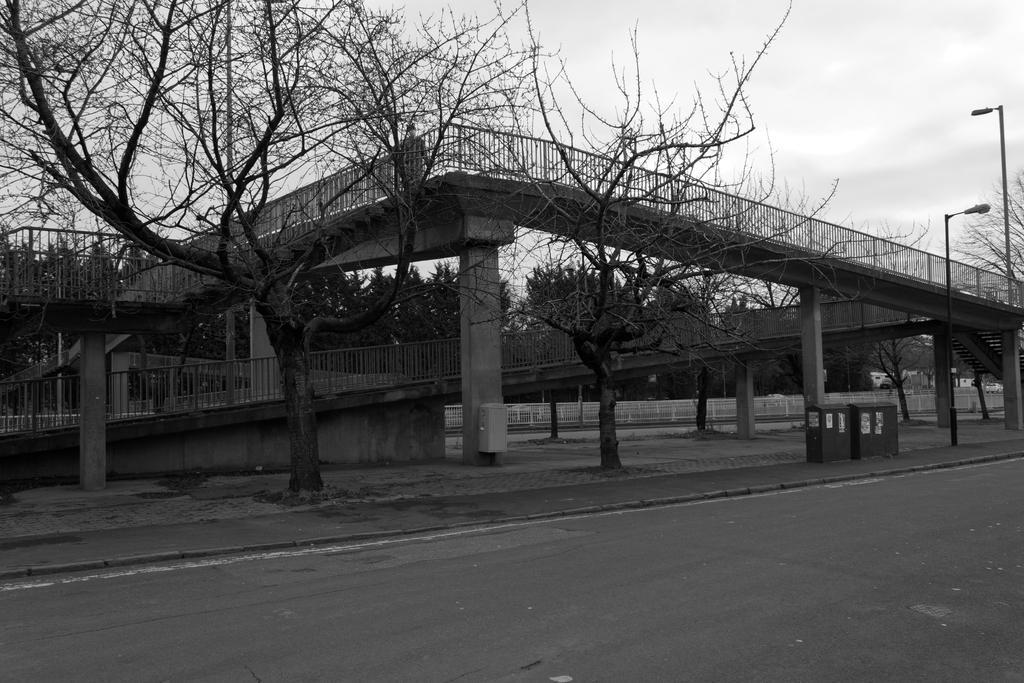How would you summarize this image in a sentence or two? In this image we can see the bridge. Behind the bridge we can see a group of trees. In front of the bridge we can see few trees. On the right side, we can see the poles with lights. At the top we can see the sky. 